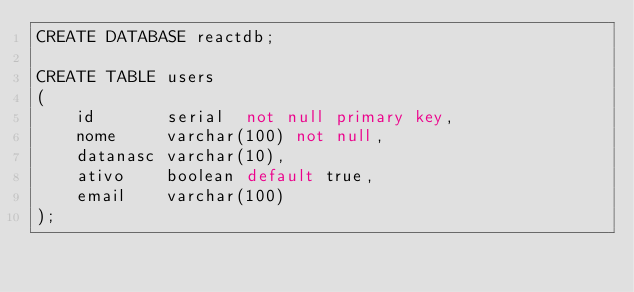<code> <loc_0><loc_0><loc_500><loc_500><_SQL_>CREATE DATABASE reactdb;

CREATE TABLE users
(
    id       serial  not null primary key,
    nome     varchar(100) not null,
    datanasc varchar(10),
    ativo    boolean default true,
    email    varchar(100)
);</code> 